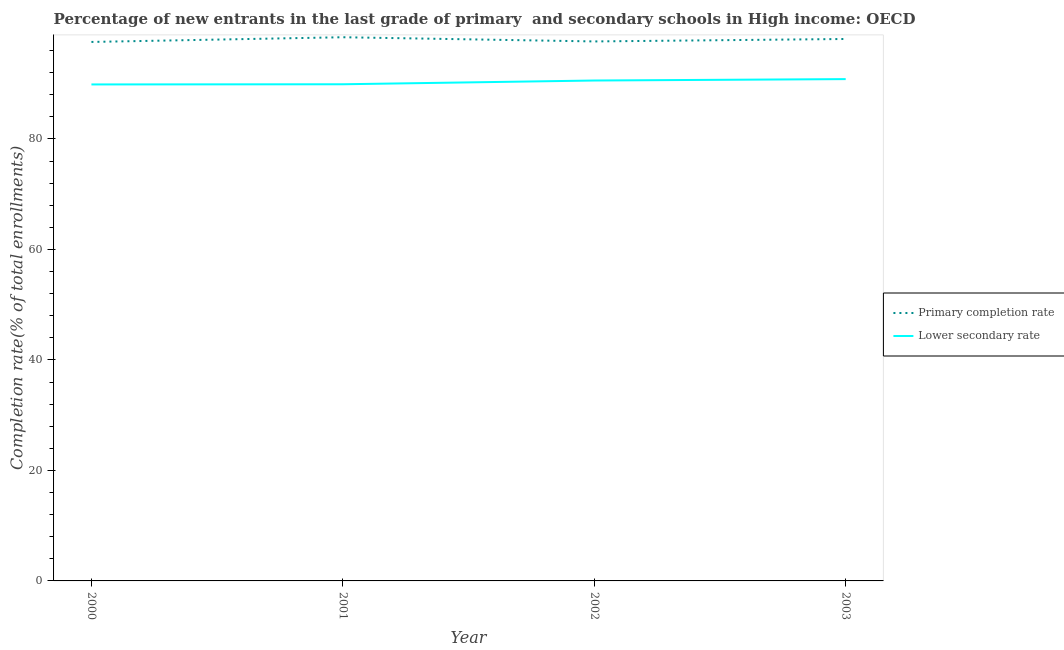How many different coloured lines are there?
Give a very brief answer. 2. Does the line corresponding to completion rate in secondary schools intersect with the line corresponding to completion rate in primary schools?
Your answer should be compact. No. What is the completion rate in secondary schools in 2001?
Your answer should be very brief. 89.9. Across all years, what is the maximum completion rate in secondary schools?
Provide a succinct answer. 90.83. Across all years, what is the minimum completion rate in primary schools?
Ensure brevity in your answer.  97.56. What is the total completion rate in secondary schools in the graph?
Provide a succinct answer. 361.18. What is the difference between the completion rate in primary schools in 2000 and that in 2003?
Your response must be concise. -0.54. What is the difference between the completion rate in primary schools in 2001 and the completion rate in secondary schools in 2002?
Your response must be concise. 7.84. What is the average completion rate in secondary schools per year?
Ensure brevity in your answer.  90.3. In the year 2001, what is the difference between the completion rate in secondary schools and completion rate in primary schools?
Keep it short and to the point. -8.51. In how many years, is the completion rate in secondary schools greater than 76 %?
Provide a short and direct response. 4. What is the ratio of the completion rate in secondary schools in 2000 to that in 2003?
Your answer should be very brief. 0.99. Is the difference between the completion rate in primary schools in 2000 and 2003 greater than the difference between the completion rate in secondary schools in 2000 and 2003?
Give a very brief answer. Yes. What is the difference between the highest and the second highest completion rate in primary schools?
Give a very brief answer. 0.32. What is the difference between the highest and the lowest completion rate in primary schools?
Make the answer very short. 0.85. In how many years, is the completion rate in secondary schools greater than the average completion rate in secondary schools taken over all years?
Give a very brief answer. 2. Is the sum of the completion rate in secondary schools in 2000 and 2002 greater than the maximum completion rate in primary schools across all years?
Make the answer very short. Yes. Does the completion rate in primary schools monotonically increase over the years?
Your response must be concise. No. How many lines are there?
Give a very brief answer. 2. Are the values on the major ticks of Y-axis written in scientific E-notation?
Your answer should be very brief. No. Does the graph contain any zero values?
Your answer should be compact. No. How many legend labels are there?
Make the answer very short. 2. How are the legend labels stacked?
Make the answer very short. Vertical. What is the title of the graph?
Offer a very short reply. Percentage of new entrants in the last grade of primary  and secondary schools in High income: OECD. What is the label or title of the X-axis?
Provide a short and direct response. Year. What is the label or title of the Y-axis?
Your response must be concise. Completion rate(% of total enrollments). What is the Completion rate(% of total enrollments) of Primary completion rate in 2000?
Give a very brief answer. 97.56. What is the Completion rate(% of total enrollments) in Lower secondary rate in 2000?
Your answer should be compact. 89.87. What is the Completion rate(% of total enrollments) in Primary completion rate in 2001?
Your response must be concise. 98.41. What is the Completion rate(% of total enrollments) of Lower secondary rate in 2001?
Your response must be concise. 89.9. What is the Completion rate(% of total enrollments) in Primary completion rate in 2002?
Offer a terse response. 97.65. What is the Completion rate(% of total enrollments) in Lower secondary rate in 2002?
Ensure brevity in your answer.  90.58. What is the Completion rate(% of total enrollments) of Primary completion rate in 2003?
Keep it short and to the point. 98.1. What is the Completion rate(% of total enrollments) of Lower secondary rate in 2003?
Offer a very short reply. 90.83. Across all years, what is the maximum Completion rate(% of total enrollments) in Primary completion rate?
Provide a succinct answer. 98.41. Across all years, what is the maximum Completion rate(% of total enrollments) in Lower secondary rate?
Offer a very short reply. 90.83. Across all years, what is the minimum Completion rate(% of total enrollments) in Primary completion rate?
Give a very brief answer. 97.56. Across all years, what is the minimum Completion rate(% of total enrollments) in Lower secondary rate?
Ensure brevity in your answer.  89.87. What is the total Completion rate(% of total enrollments) in Primary completion rate in the graph?
Make the answer very short. 391.73. What is the total Completion rate(% of total enrollments) of Lower secondary rate in the graph?
Your answer should be compact. 361.18. What is the difference between the Completion rate(% of total enrollments) of Primary completion rate in 2000 and that in 2001?
Give a very brief answer. -0.85. What is the difference between the Completion rate(% of total enrollments) in Lower secondary rate in 2000 and that in 2001?
Give a very brief answer. -0.03. What is the difference between the Completion rate(% of total enrollments) in Primary completion rate in 2000 and that in 2002?
Keep it short and to the point. -0.09. What is the difference between the Completion rate(% of total enrollments) of Lower secondary rate in 2000 and that in 2002?
Provide a short and direct response. -0.71. What is the difference between the Completion rate(% of total enrollments) in Primary completion rate in 2000 and that in 2003?
Your response must be concise. -0.54. What is the difference between the Completion rate(% of total enrollments) of Lower secondary rate in 2000 and that in 2003?
Your answer should be compact. -0.96. What is the difference between the Completion rate(% of total enrollments) in Primary completion rate in 2001 and that in 2002?
Give a very brief answer. 0.76. What is the difference between the Completion rate(% of total enrollments) of Lower secondary rate in 2001 and that in 2002?
Offer a terse response. -0.68. What is the difference between the Completion rate(% of total enrollments) of Primary completion rate in 2001 and that in 2003?
Provide a succinct answer. 0.32. What is the difference between the Completion rate(% of total enrollments) in Lower secondary rate in 2001 and that in 2003?
Keep it short and to the point. -0.93. What is the difference between the Completion rate(% of total enrollments) of Primary completion rate in 2002 and that in 2003?
Your answer should be very brief. -0.44. What is the difference between the Completion rate(% of total enrollments) of Lower secondary rate in 2002 and that in 2003?
Provide a succinct answer. -0.26. What is the difference between the Completion rate(% of total enrollments) in Primary completion rate in 2000 and the Completion rate(% of total enrollments) in Lower secondary rate in 2001?
Your answer should be compact. 7.66. What is the difference between the Completion rate(% of total enrollments) in Primary completion rate in 2000 and the Completion rate(% of total enrollments) in Lower secondary rate in 2002?
Give a very brief answer. 6.98. What is the difference between the Completion rate(% of total enrollments) of Primary completion rate in 2000 and the Completion rate(% of total enrollments) of Lower secondary rate in 2003?
Your answer should be compact. 6.73. What is the difference between the Completion rate(% of total enrollments) in Primary completion rate in 2001 and the Completion rate(% of total enrollments) in Lower secondary rate in 2002?
Provide a short and direct response. 7.84. What is the difference between the Completion rate(% of total enrollments) of Primary completion rate in 2001 and the Completion rate(% of total enrollments) of Lower secondary rate in 2003?
Give a very brief answer. 7.58. What is the difference between the Completion rate(% of total enrollments) in Primary completion rate in 2002 and the Completion rate(% of total enrollments) in Lower secondary rate in 2003?
Keep it short and to the point. 6.82. What is the average Completion rate(% of total enrollments) in Primary completion rate per year?
Give a very brief answer. 97.93. What is the average Completion rate(% of total enrollments) in Lower secondary rate per year?
Provide a short and direct response. 90.3. In the year 2000, what is the difference between the Completion rate(% of total enrollments) of Primary completion rate and Completion rate(% of total enrollments) of Lower secondary rate?
Keep it short and to the point. 7.69. In the year 2001, what is the difference between the Completion rate(% of total enrollments) in Primary completion rate and Completion rate(% of total enrollments) in Lower secondary rate?
Make the answer very short. 8.51. In the year 2002, what is the difference between the Completion rate(% of total enrollments) of Primary completion rate and Completion rate(% of total enrollments) of Lower secondary rate?
Ensure brevity in your answer.  7.08. In the year 2003, what is the difference between the Completion rate(% of total enrollments) in Primary completion rate and Completion rate(% of total enrollments) in Lower secondary rate?
Your answer should be compact. 7.26. What is the ratio of the Completion rate(% of total enrollments) in Lower secondary rate in 2000 to that in 2001?
Make the answer very short. 1. What is the ratio of the Completion rate(% of total enrollments) of Primary completion rate in 2000 to that in 2002?
Offer a terse response. 1. What is the ratio of the Completion rate(% of total enrollments) of Primary completion rate in 2001 to that in 2002?
Your response must be concise. 1.01. What is the ratio of the Completion rate(% of total enrollments) of Lower secondary rate in 2001 to that in 2002?
Provide a succinct answer. 0.99. What is the ratio of the Completion rate(% of total enrollments) of Primary completion rate in 2001 to that in 2003?
Your response must be concise. 1. What is the difference between the highest and the second highest Completion rate(% of total enrollments) of Primary completion rate?
Ensure brevity in your answer.  0.32. What is the difference between the highest and the second highest Completion rate(% of total enrollments) in Lower secondary rate?
Make the answer very short. 0.26. What is the difference between the highest and the lowest Completion rate(% of total enrollments) in Primary completion rate?
Offer a terse response. 0.85. What is the difference between the highest and the lowest Completion rate(% of total enrollments) in Lower secondary rate?
Your response must be concise. 0.96. 